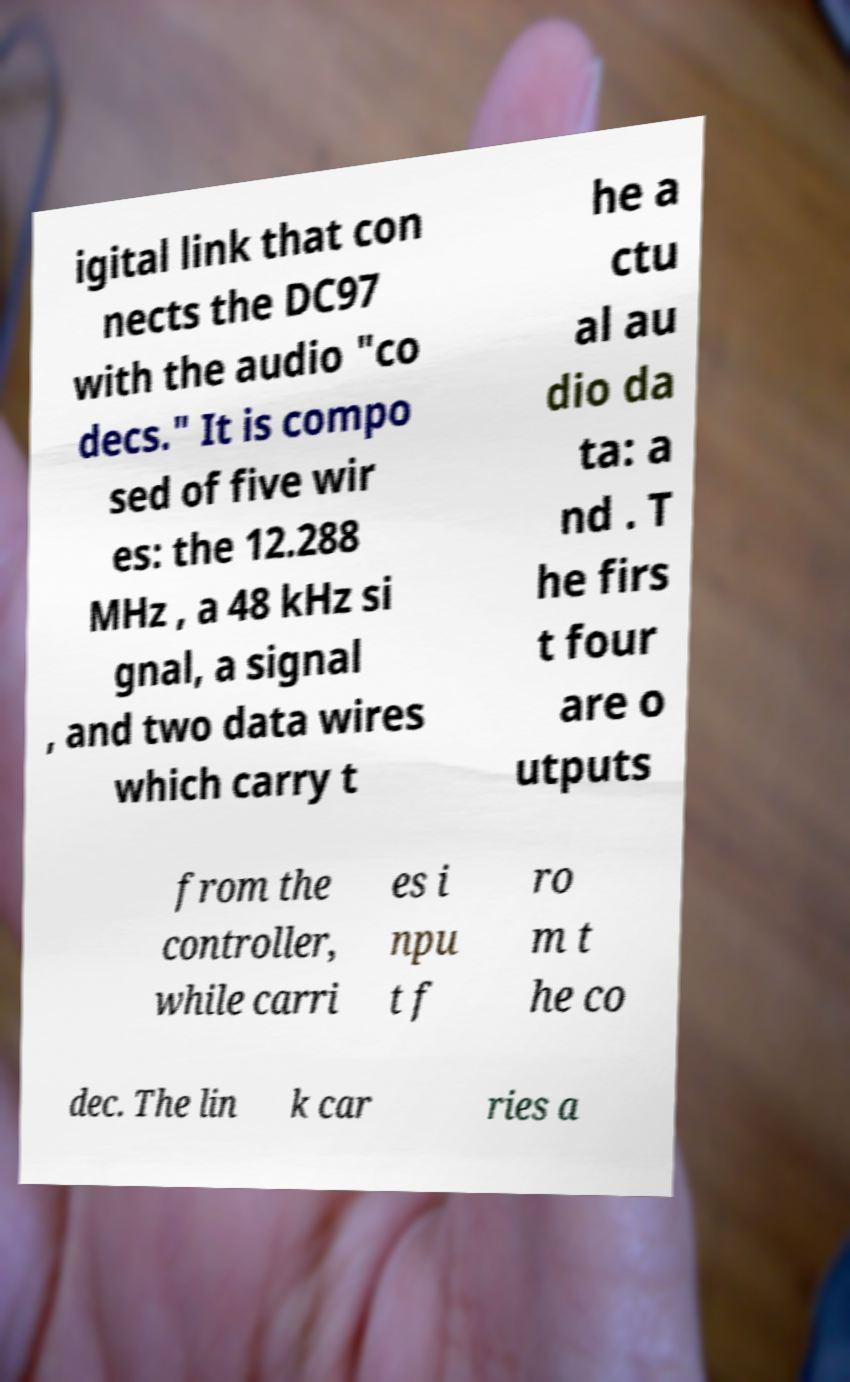Please read and relay the text visible in this image. What does it say? igital link that con nects the DC97 with the audio "co decs." It is compo sed of five wir es: the 12.288 MHz , a 48 kHz si gnal, a signal , and two data wires which carry t he a ctu al au dio da ta: a nd . T he firs t four are o utputs from the controller, while carri es i npu t f ro m t he co dec. The lin k car ries a 